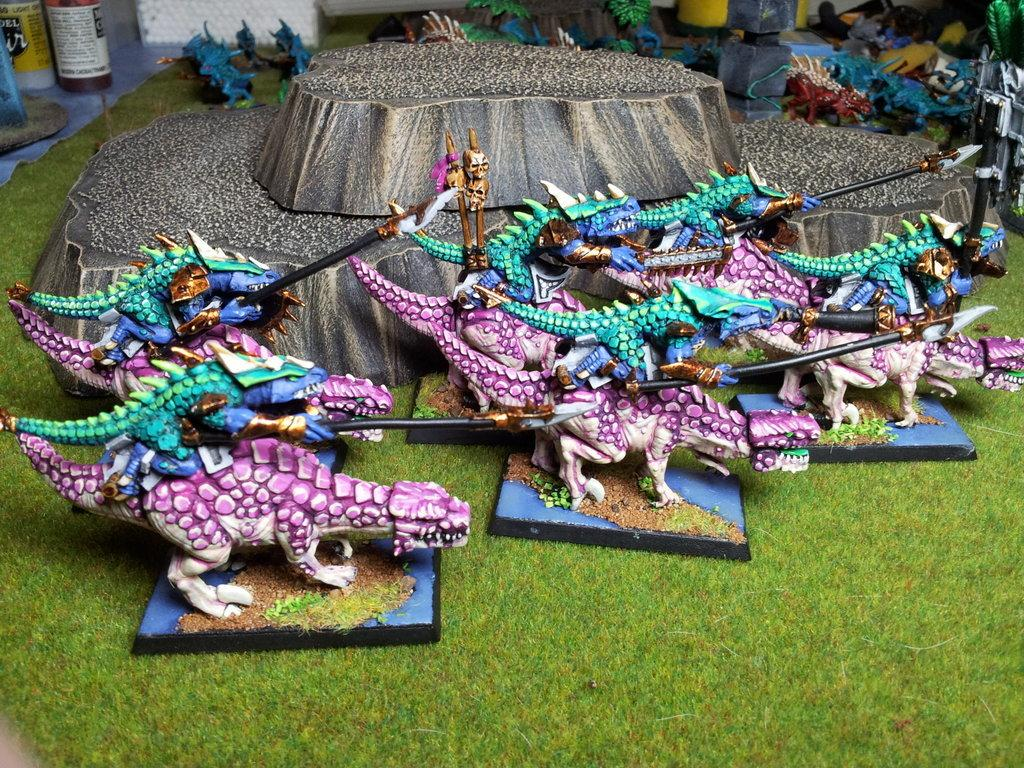What type of toys are on the ground in the image? There are dinosaur toys on the ground in the image. What type of vegetation is visible in the image? There is grass visible in the image. What geological feature is present in the image? There is a rock in the image. What type of dress is hanging from the icicle in the image? There is no icicle or dress present in the image. 